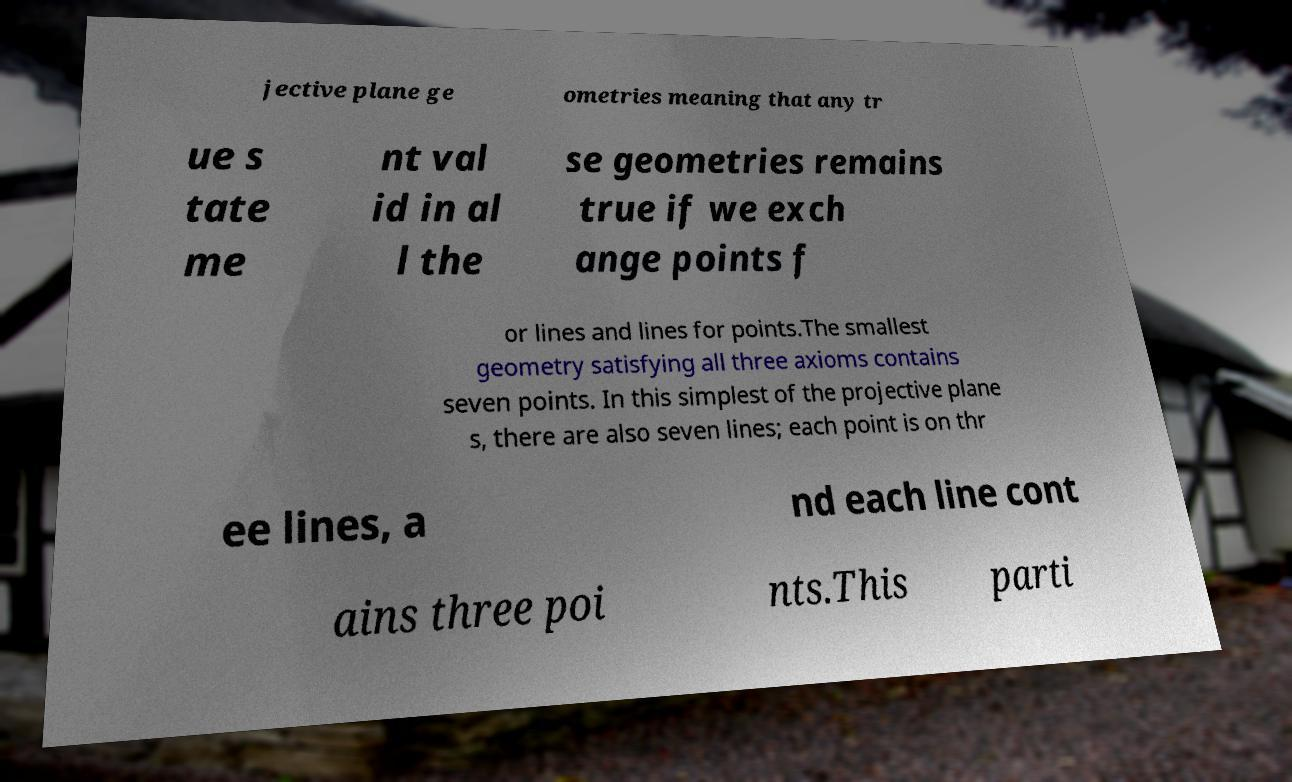Could you assist in decoding the text presented in this image and type it out clearly? jective plane ge ometries meaning that any tr ue s tate me nt val id in al l the se geometries remains true if we exch ange points f or lines and lines for points.The smallest geometry satisfying all three axioms contains seven points. In this simplest of the projective plane s, there are also seven lines; each point is on thr ee lines, a nd each line cont ains three poi nts.This parti 